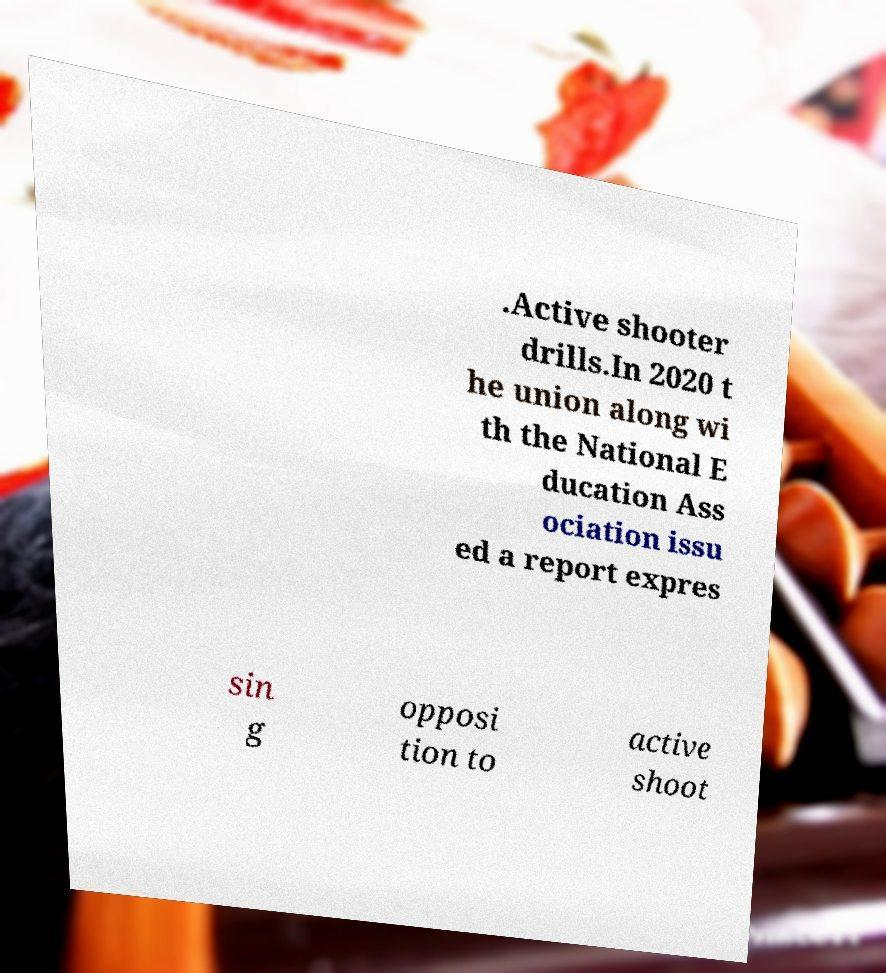What messages or text are displayed in this image? I need them in a readable, typed format. .Active shooter drills.In 2020 t he union along wi th the National E ducation Ass ociation issu ed a report expres sin g opposi tion to active shoot 